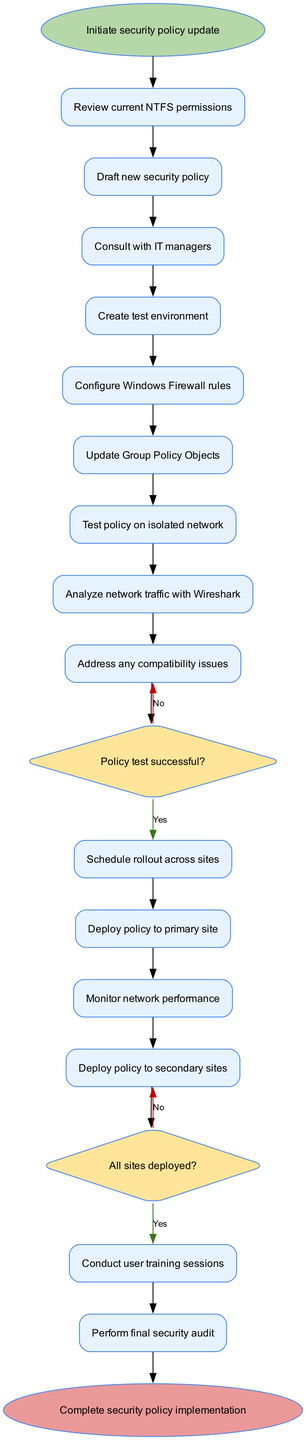What is the first activity in the diagram? The first activity directly connected to the start node is "Review current NTFS permissions", which follows immediately after initiating the security policy update.
Answer: Review current NTFS permissions Which decision node follows the activity "Test policy on isolated network"? The decision node that follows "Test policy on isolated network" is regarding whether the policy test was successful or not. This decision determines the next steps based on the outcome of the previous activity.
Answer: Policy test successful? How many activities are there in total? By counting the activities listed in the diagram, there are a total of 14 distinct activities included in the implementation process.
Answer: 14 What action is taken if the policy test is unsuccessful? If the policy test is determined to be unsuccessful, the next action taken is to "Address any compatibility issues" based on the decision made at that point in the flow.
Answer: Address any compatibility issues What is the last activity before the end node? The last activity that occurs just before reaching the end node is "Perform final security audit", which is an essential step before completing the implementation.
Answer: Perform final security audit How many decision nodes are present in the diagram? In the diagram, there are 2 decision nodes present, corresponding to the evaluations of the policy test and the deployment status across all sites.
Answer: 2 What happens after all sites have deployed the policy? Once all sites have deployed the policy, the subsequent action is to "Conduct user training sessions", ensuring users are informed and prepared for the new security policy.
Answer: Conduct user training sessions Which activity involves analyzing network traffic? The activity that specifically mentions the analysis of network traffic is "Analyze network traffic with Wireshark", highlighting the importance of monitoring security post-implementation.
Answer: Analyze network traffic with Wireshark 